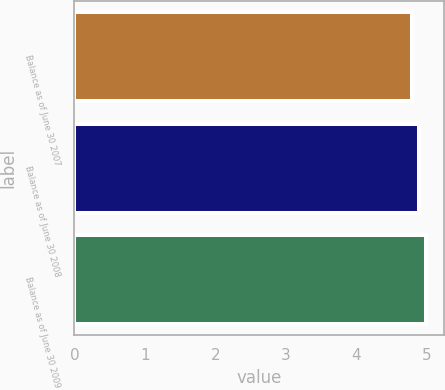Convert chart to OTSL. <chart><loc_0><loc_0><loc_500><loc_500><bar_chart><fcel>Balance as of June 30 2007<fcel>Balance as of June 30 2008<fcel>Balance as of June 30 2009<nl><fcel>4.8<fcel>4.9<fcel>5<nl></chart> 